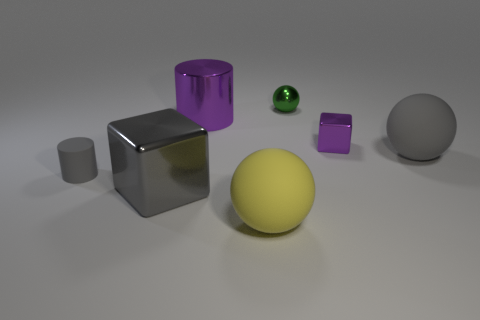How many objects are big gray matte objects or large balls that are behind the large yellow ball?
Keep it short and to the point. 1. What material is the cylinder behind the gray matte object that is in front of the large rubber object right of the tiny shiny ball?
Your answer should be compact. Metal. There is a cylinder behind the gray rubber sphere; does it have the same color as the tiny cube?
Offer a terse response. Yes. What number of yellow things are either large metal cylinders or metallic cubes?
Keep it short and to the point. 0. What number of other objects are the same shape as the large purple shiny object?
Ensure brevity in your answer.  1. Does the tiny gray object have the same material as the yellow thing?
Ensure brevity in your answer.  Yes. What is the tiny thing that is both in front of the purple cylinder and right of the big purple shiny thing made of?
Keep it short and to the point. Metal. What is the color of the block that is to the left of the large metal cylinder?
Ensure brevity in your answer.  Gray. Are there more shiny things that are left of the purple cylinder than tiny blue metallic cylinders?
Your answer should be very brief. Yes. How many other things are the same size as the gray rubber sphere?
Offer a terse response. 3. 